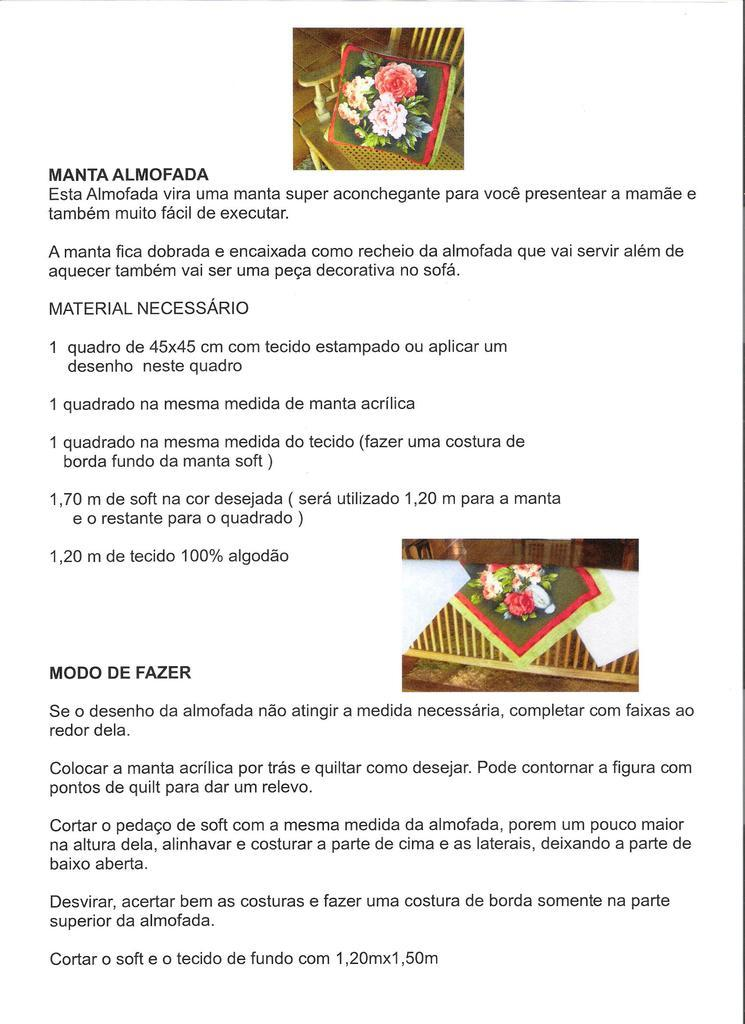What type of pen is being used to write on the slip of cloth in the image? There is no image or reference to a pen, slip, or cloth in the provided information. What type of pen is being used to write on the slip of cloth in the image? There is no image or reference to a pen, slip, or cloth in the provided information. 